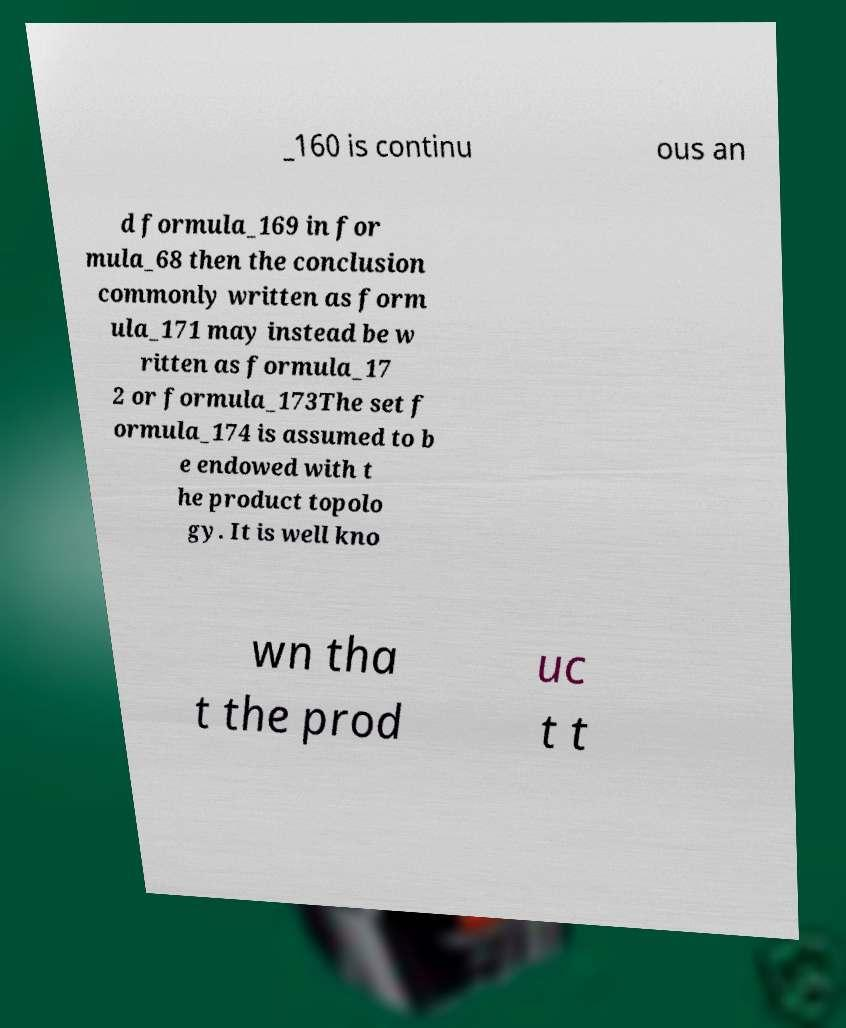For documentation purposes, I need the text within this image transcribed. Could you provide that? _160 is continu ous an d formula_169 in for mula_68 then the conclusion commonly written as form ula_171 may instead be w ritten as formula_17 2 or formula_173The set f ormula_174 is assumed to b e endowed with t he product topolo gy. It is well kno wn tha t the prod uc t t 